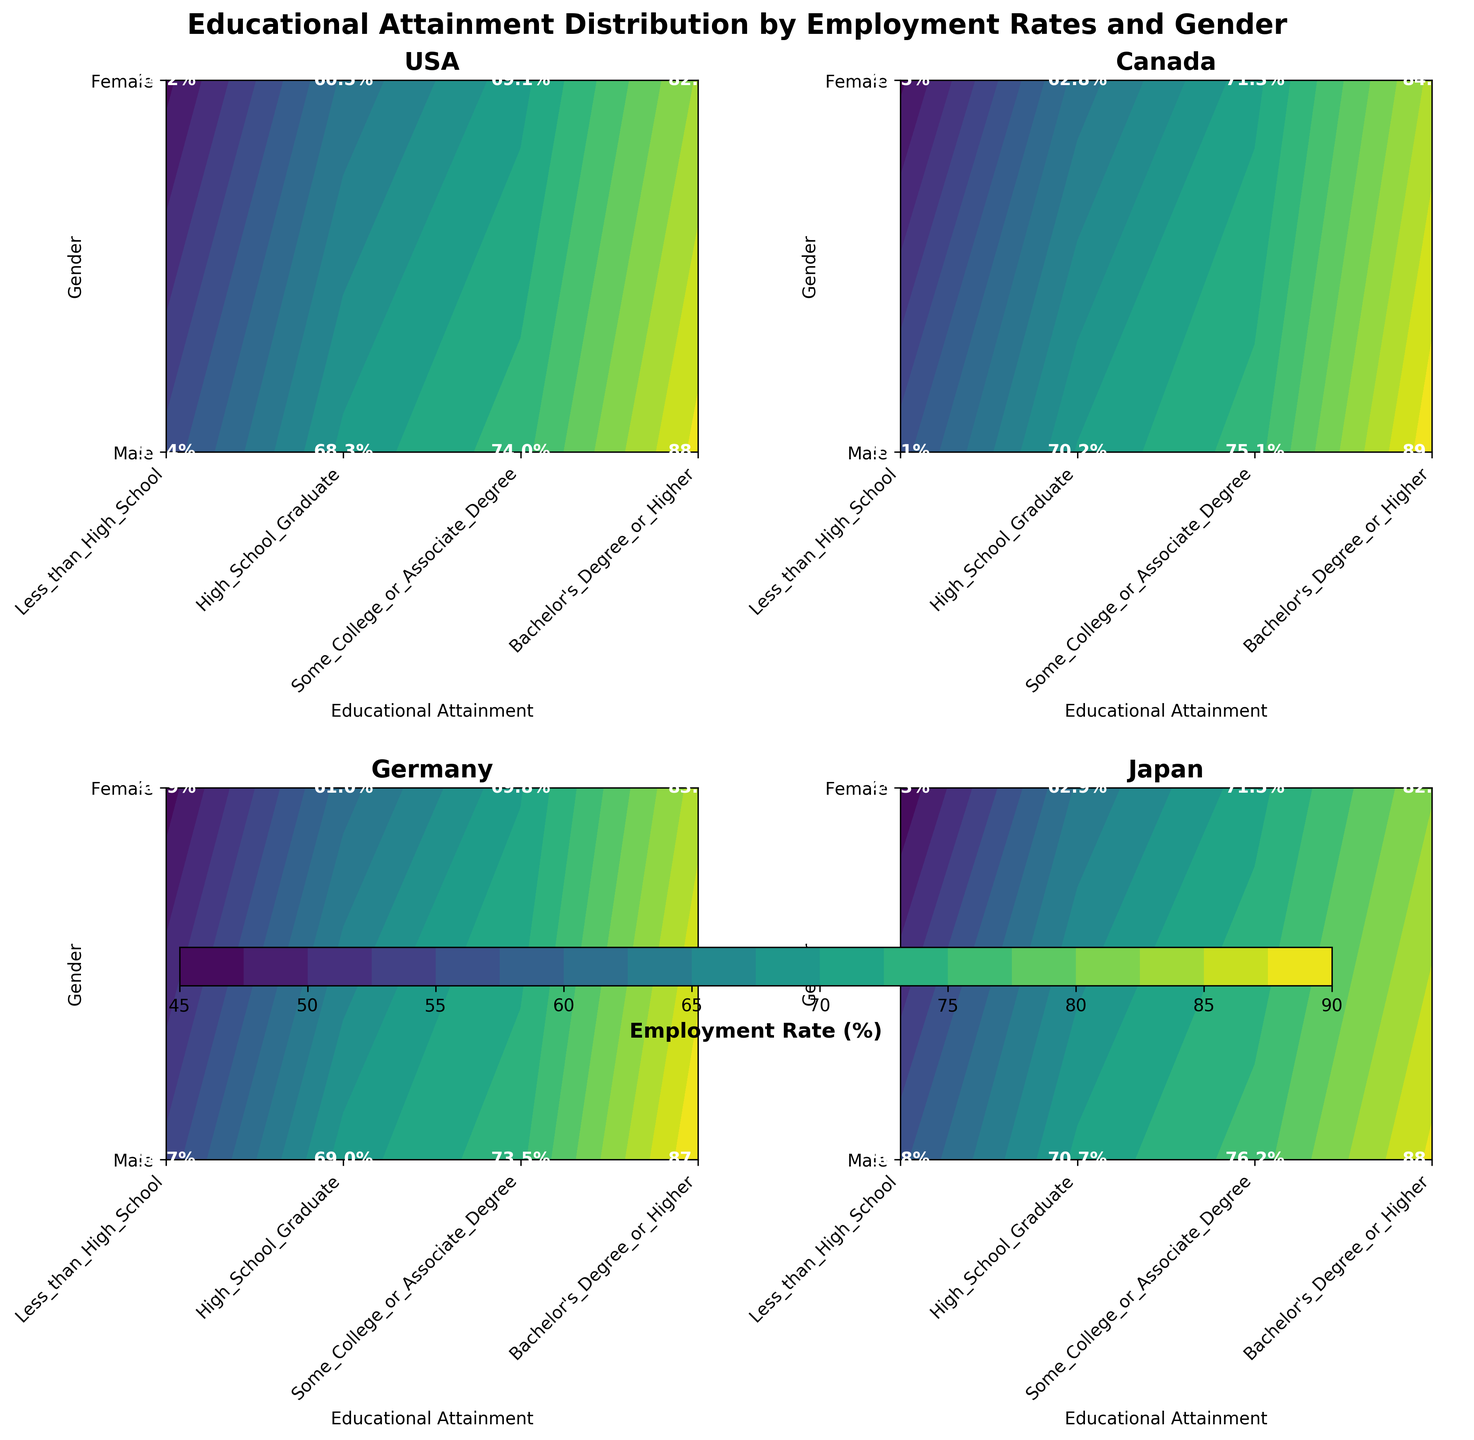What is the title of the figure? The title is usually written at the top of the figure in bold, larger font size.
Answer: Educational Attainment Distribution by Employment Rates and Gender How many countries are included in the plot? Each subplot represents a different country. Counting the number of subplots will give the number of countries.
Answer: 4 Which educational attainment level generally shows the highest employment rates across all countries? Look at the highest values within the contours for each country. Each highest point corresponds to "Bachelor's Degree or Higher" across the countries.
Answer: Bachelor's Degree or Higher What is the employment rate for females with high school graduation in the USA? Locate the USA subplot, find the "High School Graduate" level on the x-axis and the "Female" on the y-axis. The value within the contour at this point is marked.
Answer: 60.5% In which country do males with less than high school education have the highest unemployment rate? Compare the values for "Less_than_High_School" for males across all countries.
Answer: USA What is the difference in employment rates between males and females with some college or associate degree in Japan? Locate the Japan subplot and check the values for "Some_College_or_Associate_Degree" for both males and females. Subtract the female rate from the male rate.
Answer: 4.7% Which country has the smallest gap between male and female employment rates for high school graduates? For each country subplot, calculate the difference in employment rates for "High_School_Graduate" between males and females. The smallest gap is in Germany.
Answer: Germany Based on the contour colors, which country shows the most equal distribution of employment rates across genders for all education levels? Look for the subplot with the most similar colors between the male and female y-axis ticks.
Answer: Japan How does the employment of females with a Bachelor's degree or higher in Germany compare with that in Canada? Compare the values for "Bachelor's_Degree_or_Higher" for females in Germany and Canada subplots.
Answer: Germany: 83.0%, Canada: 84.6% For males in Canada, how does the employment rate increase as educational attainment increases from less than high school to a Bachelor's degree or higher? Check the values for "Less_than_High_School", "High_School_Graduate", "Some_College_or_Associate_Degree", and "Bachelor's_Degree_or_Higher" for males in Canada and note the increase.
Answer: 57.1% to 89.5% 